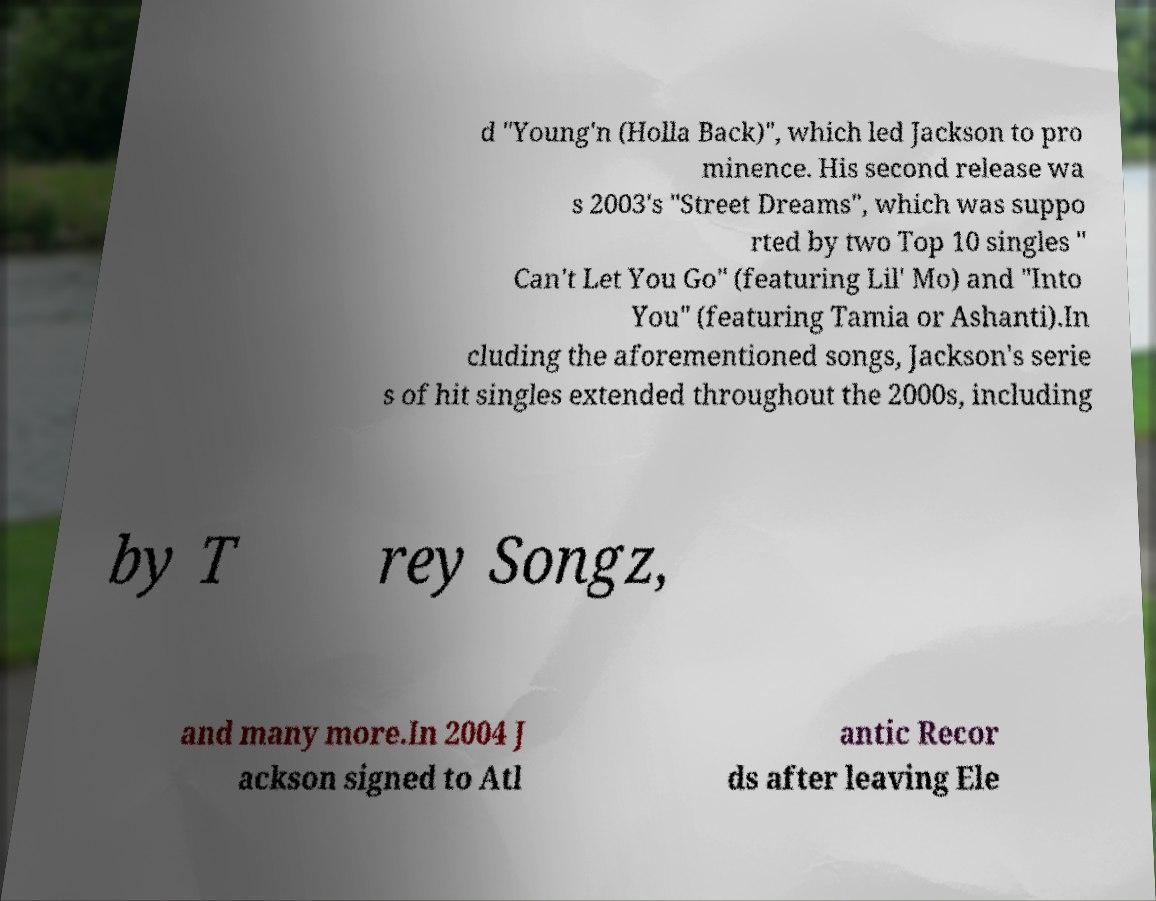Could you assist in decoding the text presented in this image and type it out clearly? d "Young'n (Holla Back)", which led Jackson to pro minence. His second release wa s 2003's "Street Dreams", which was suppo rted by two Top 10 singles " Can't Let You Go" (featuring Lil' Mo) and "Into You" (featuring Tamia or Ashanti).In cluding the aforementioned songs, Jackson's serie s of hit singles extended throughout the 2000s, including by T rey Songz, and many more.In 2004 J ackson signed to Atl antic Recor ds after leaving Ele 